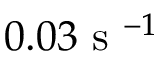<formula> <loc_0><loc_0><loc_500><loc_500>0 . 0 3 s ^ { - 1 }</formula> 